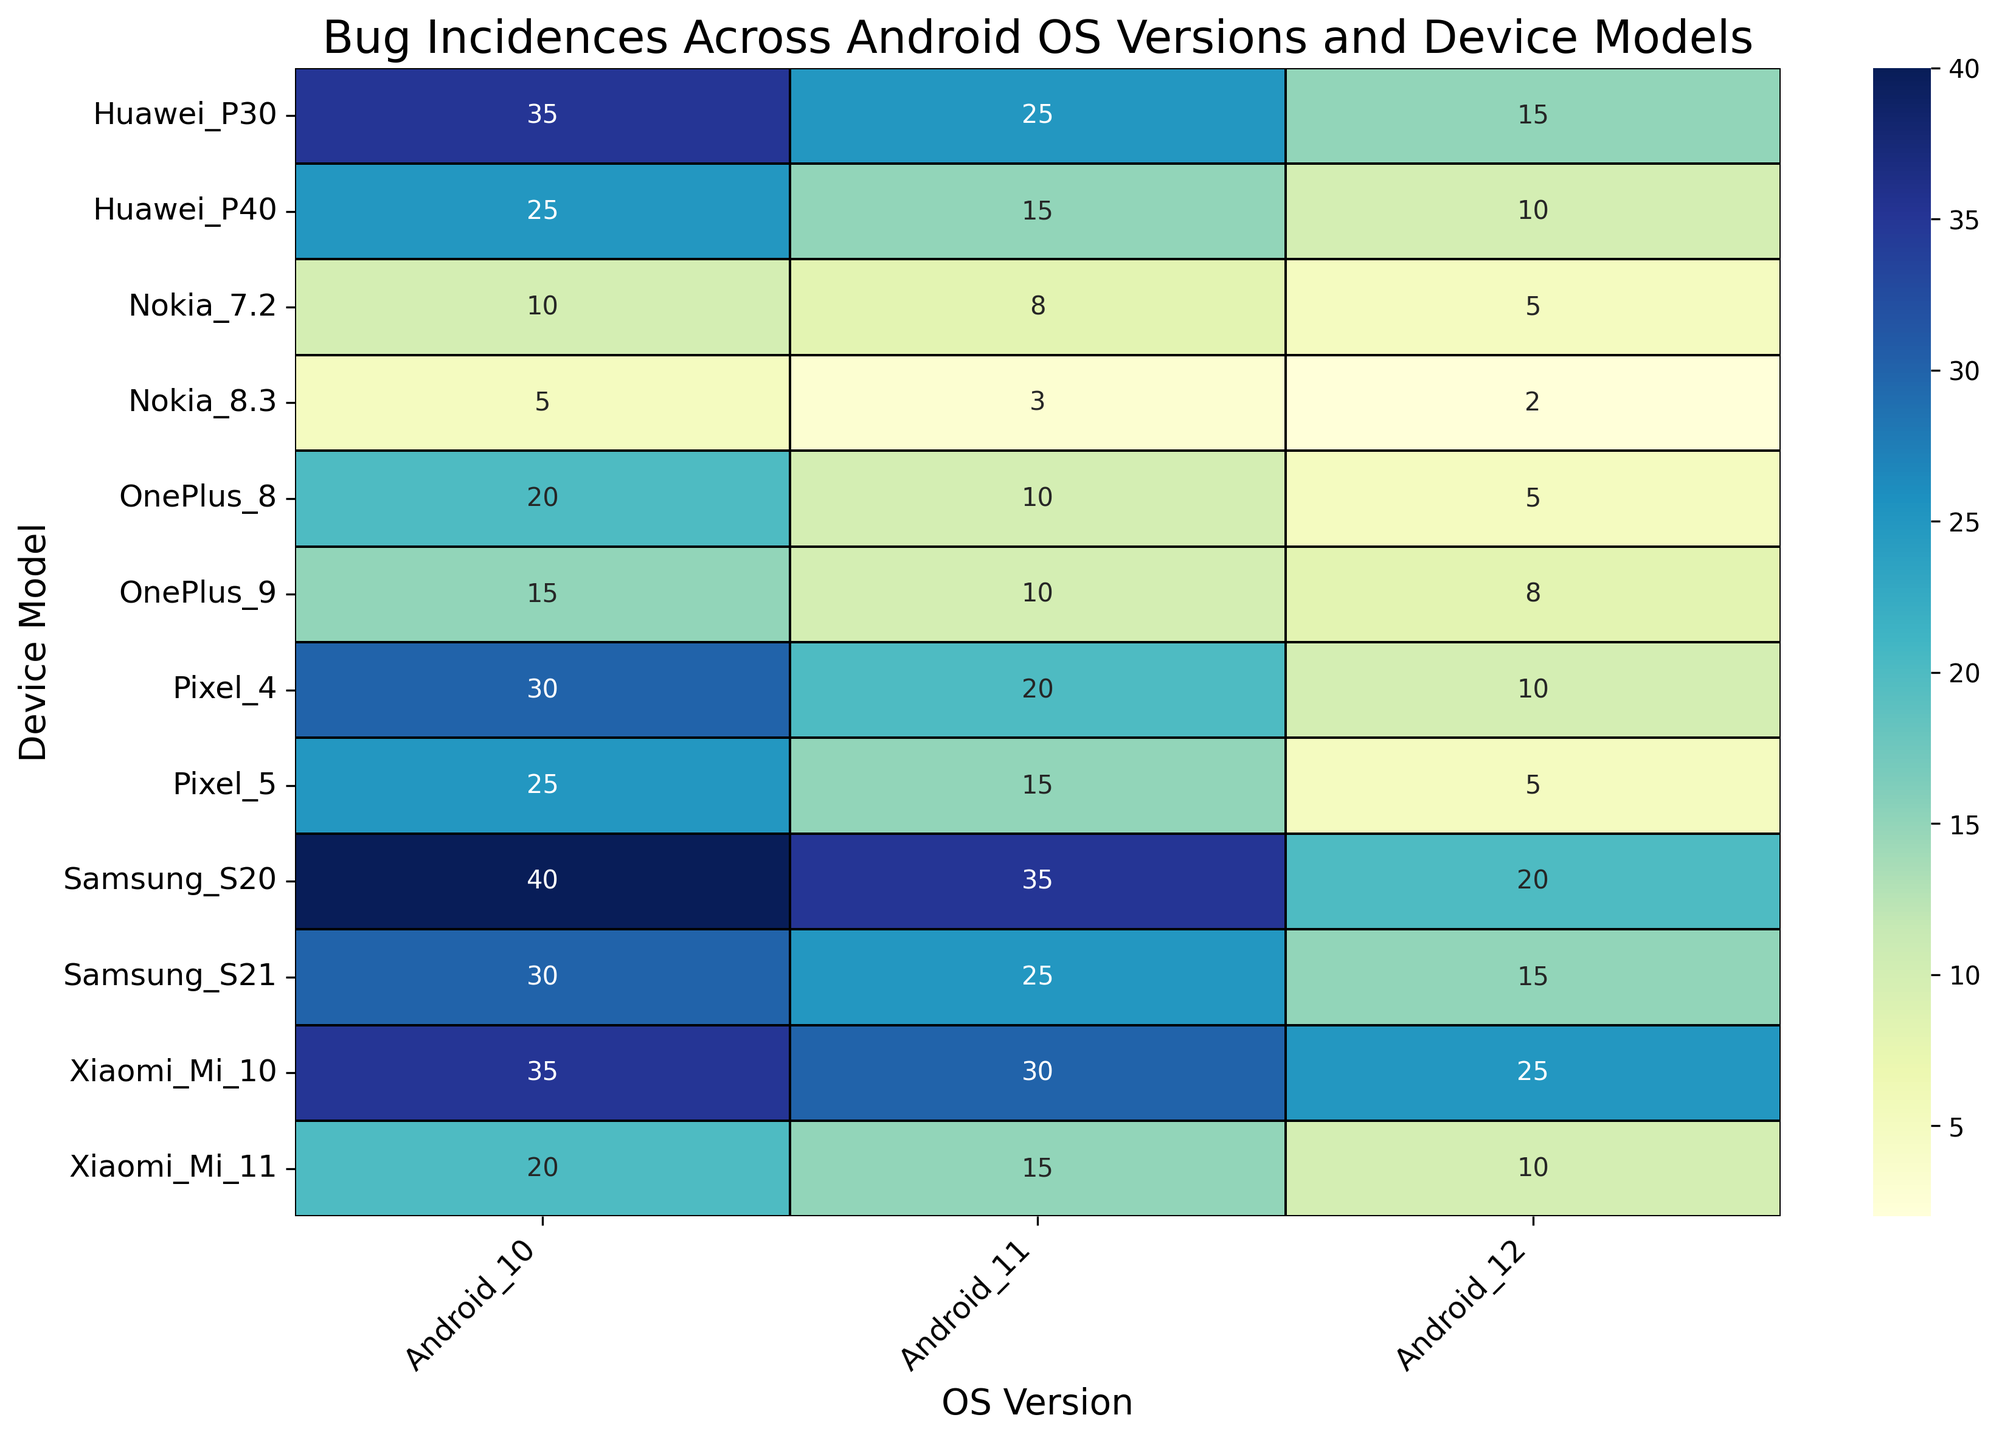What device model has the highest number of bug incidences for Android 10? Look at the column for Android 10 and identify the highest number, which is 40 for the Samsung S20.
Answer: Samsung S20 Which OS version has the lowest number of bug incidences for the Pixel 4? Look at the row for Pixel 4, the lowest number is 10 in the column for Android 12.
Answer: Android 12 How do the bug incidences for the OnePlus 8 compare across different OS versions? Look at the row for OnePlus 8 and compare the values across the columns: Android 10 (20), Android 11 (10), and Android 12 (5). There is a decreasing trend.
Answer: Decreasing trend What is the average number of bug incidences for Android 11 across all devices? Sum the values in the column for Android 11 (20+15+35+25+10+10+8+3+30+15+25+15) and divide by the number of devices (12). The sum is 211, so the average is 211/12 ≈ 17.58.
Answer: 17.58 Is there any device model that has consistently decreasing bug incidences across all OS versions? Check each device row: Pixel 4 (30->20->10), Pixel 5 (25->15->5), Samsung S20 (40->35->20), Samsung S21 (30->25->15), OnePlus 8 (20->10->5), OnePlus 9 (15->10->8), Nokia 7.2 (10->8->5), Nokia 8.3 (5->3->2), Xiaomi Mi 10 (35->30->25), Xiaomi Mi 11 (20->15->10), Huawei P30 (35->25->15), Huawei P40 (25->15->10).
Answer: Yes What color indicates the highest number of bug incidences and what instance does it correspond to? The darkest blue color typically represents the highest value, which can be cross-referenced with 40 for Samsung S20 on Android 10.
Answer: Darkest blue, Samsung S20 on Android 10 What's the difference in bug incidences between the highest and lowest reported values for Nokia 8.3? Look at the row for Nokia 8.3: the highest value is 5 (Android 10) and the lowest value is 2 (Android 12). The difference is 5 - 2 = 3.
Answer: 3 